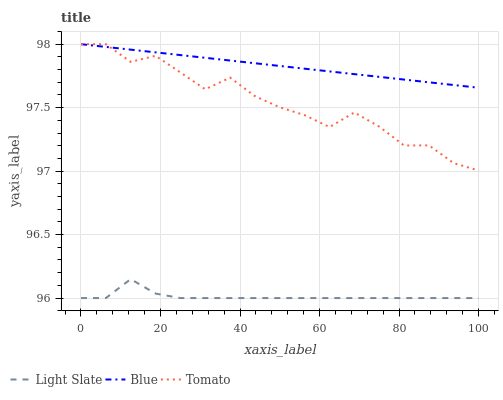Does Light Slate have the minimum area under the curve?
Answer yes or no. Yes. Does Tomato have the minimum area under the curve?
Answer yes or no. No. Does Tomato have the maximum area under the curve?
Answer yes or no. No. Is Tomato the smoothest?
Answer yes or no. No. Is Blue the roughest?
Answer yes or no. No. Does Tomato have the lowest value?
Answer yes or no. No. Is Light Slate less than Blue?
Answer yes or no. Yes. Is Blue greater than Light Slate?
Answer yes or no. Yes. Does Light Slate intersect Blue?
Answer yes or no. No. 